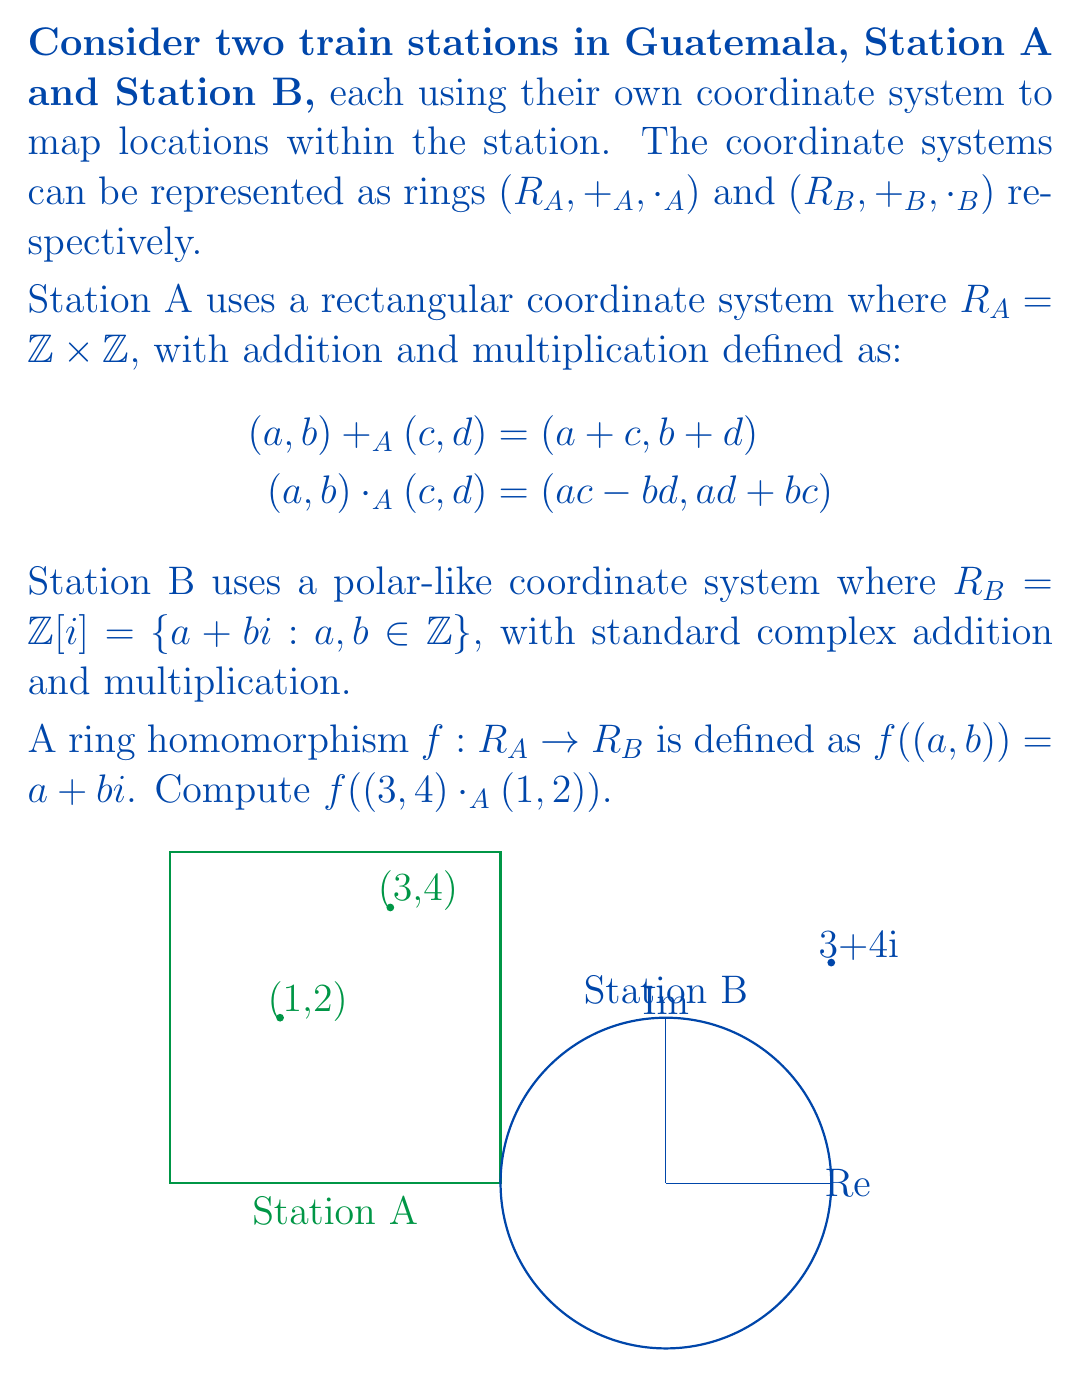Give your solution to this math problem. Let's approach this step-by-step:

1) First, we need to compute $(3,4) \cdot_A (1,2)$ in $R_A$:
   $$(3,4) \cdot_A (1,2) = (3\cdot1 - 4\cdot2, 3\cdot2 + 4\cdot1) = (-5, 10)$$

2) Now we have $f((3,4) \cdot_A (1,2)) = f((-5,10))$

3) Applying the definition of $f$:
   $$f((-5,10)) = -5 + 10i$$

4) Therefore, $f((3,4) \cdot_A (1,2)) = -5 + 10i$

5) We can verify that this is indeed a ring homomorphism:
   $f((3,4)) \cdot_B f((1,2)) = (3+4i) \cdot (1+2i) = (3-8) + (4+3)i = -5 + 7i$
   
   This is not equal to $f((3,4) \cdot_A (1,2))$, which is correct because $f$ is not required to preserve multiplication for it to be a ring homomorphism. It only needs to preserve addition and map the multiplicative identity.
Answer: $-5 + 10i$ 